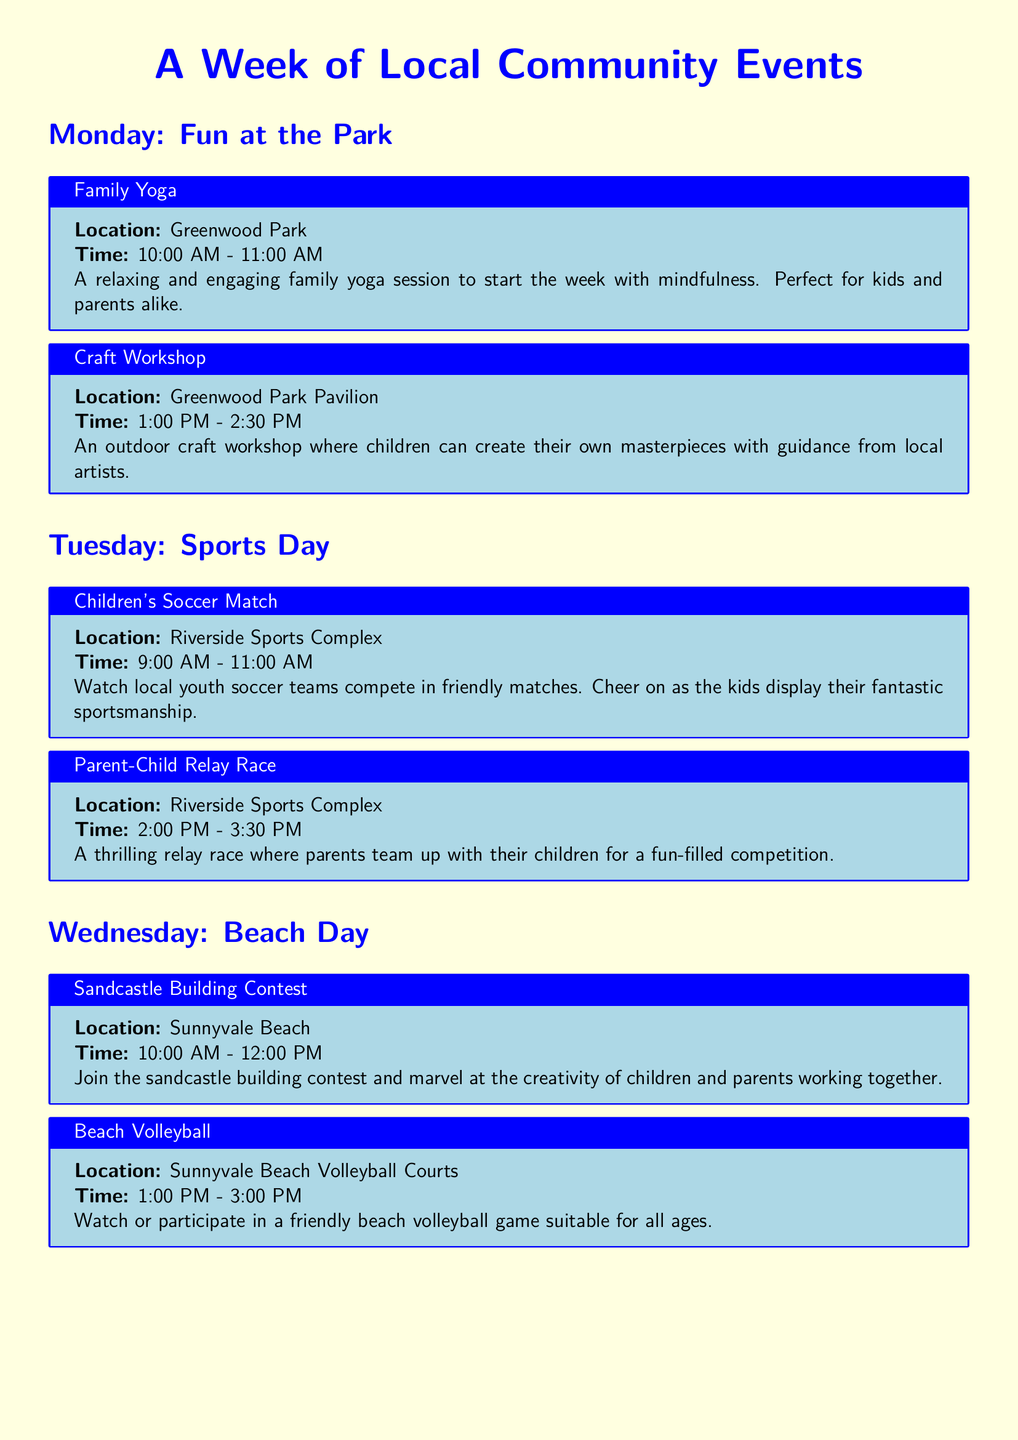What time does the Family Yoga session start? The Family Yoga session is scheduled to begin at 10:00 AM on Monday.
Answer: 10:00 AM Where will the Children's Theater Performance take place? The Children's Theater Performance will be held at Brighton Community Center.
Answer: Brighton Community Center What activity takes place at Riverside Sports Complex on Tuesday? On Tuesday, there is a Children's Soccer Match taking place at Riverside Sports Complex.
Answer: Children's Soccer Match How long is the Interactive Music Workshop? The Interactive Music Workshop lasts for 1.5 hours, from 2:00 PM to 3:30 PM.
Answer: 1.5 hours What event occurs on Saturday at Main Street? A Kids' Parade occurs on Saturday at Main Street.
Answer: Kids' Parade Which event includes storytelling for children? The Picnic and Storytelling event includes storytelling aimed at children.
Answer: Picnic and Storytelling What time does the Family Bike Ride start on Sunday? The Family Bike Ride starts at 9 AM on Sunday.
Answer: 9 AM Which location hosts a Sandcastle Building Contest? The Sandcastle Building Contest will take place at Sunnyvale Beach.
Answer: Sunnyvale Beach What type of workshop is being held at Evergreen Nature Reserve on Thursday? A Guided Nature Walk is being held at Evergreen Nature Reserve on Thursday.
Answer: Guided Nature Walk 